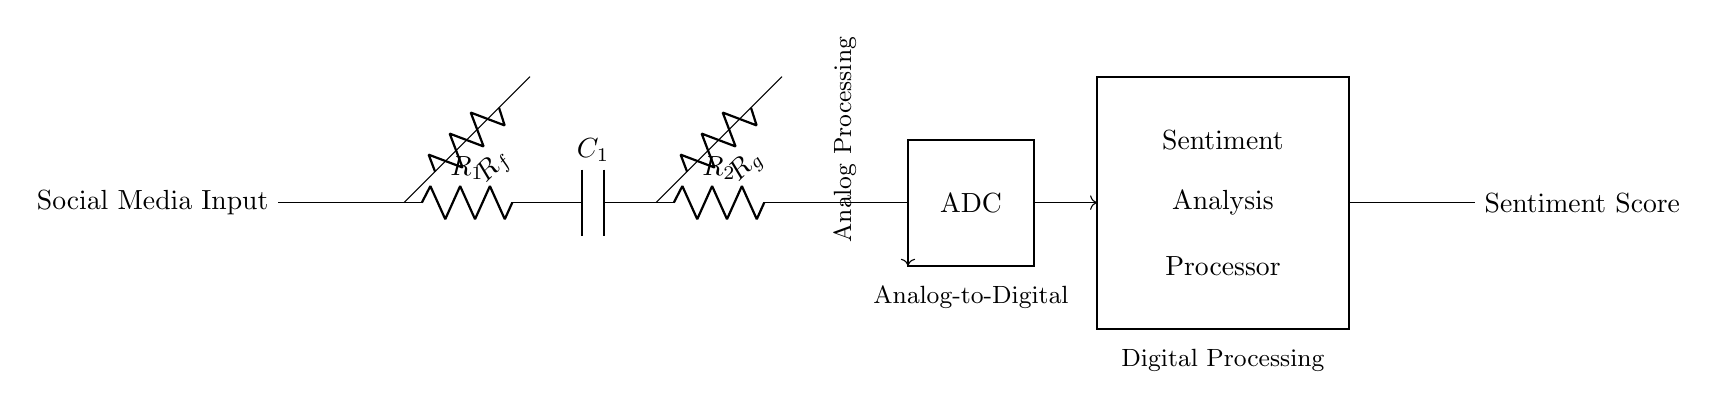What are the components in the analog processing section? The analog processing section consists of two resistors, two capacitors, and two operational amplifiers. These are labeled R1, R2, C1, and A1, A2 respectively.
Answer: Two resistors, two capacitors, two operational amplifiers What is the function of the ADC in this circuit? The ADC, which stands for Analog to Digital Converter, transforms the analog signals processed from social media inputs into digital signals for further analysis.
Answer: Converts analog signals to digital How many operational amplifiers are present in the circuit? There are two operational amplifiers indicated in the analog part of the circuit, A1 and A2.
Answer: Two What indicates that this is a hybrid circuit? The circuit consists of both analog components (like resistors and operational amplifiers) and a digital component (the ADC and the sentiment processor), showcasing features of both types.
Answer: Analog and digital components What does the sentiment analysis processor do? The sentiment analysis processor evaluates and categorizes the sentiment score based on the processed data from the ADC, allowing for the measurement of public sentiment from social media inputs.
Answer: Analyzes sentiment scores What flows from the ADC to the sentiment analysis processor? The output from the ADC, which consists of the digitized representation of the analog processed social media signals, flows through to the sentiment analysis processor to evaluate sentiment.
Answer: Digital signals How does the analog processing affect the sentiment score calculation? The analog processing, including filtering and amplification by the operational amplifiers and associated resistors and capacitors, conditions the input data to ensure accurate representation before digital conversion and analysis for sentiment scoring.
Answer: It conditions input data 